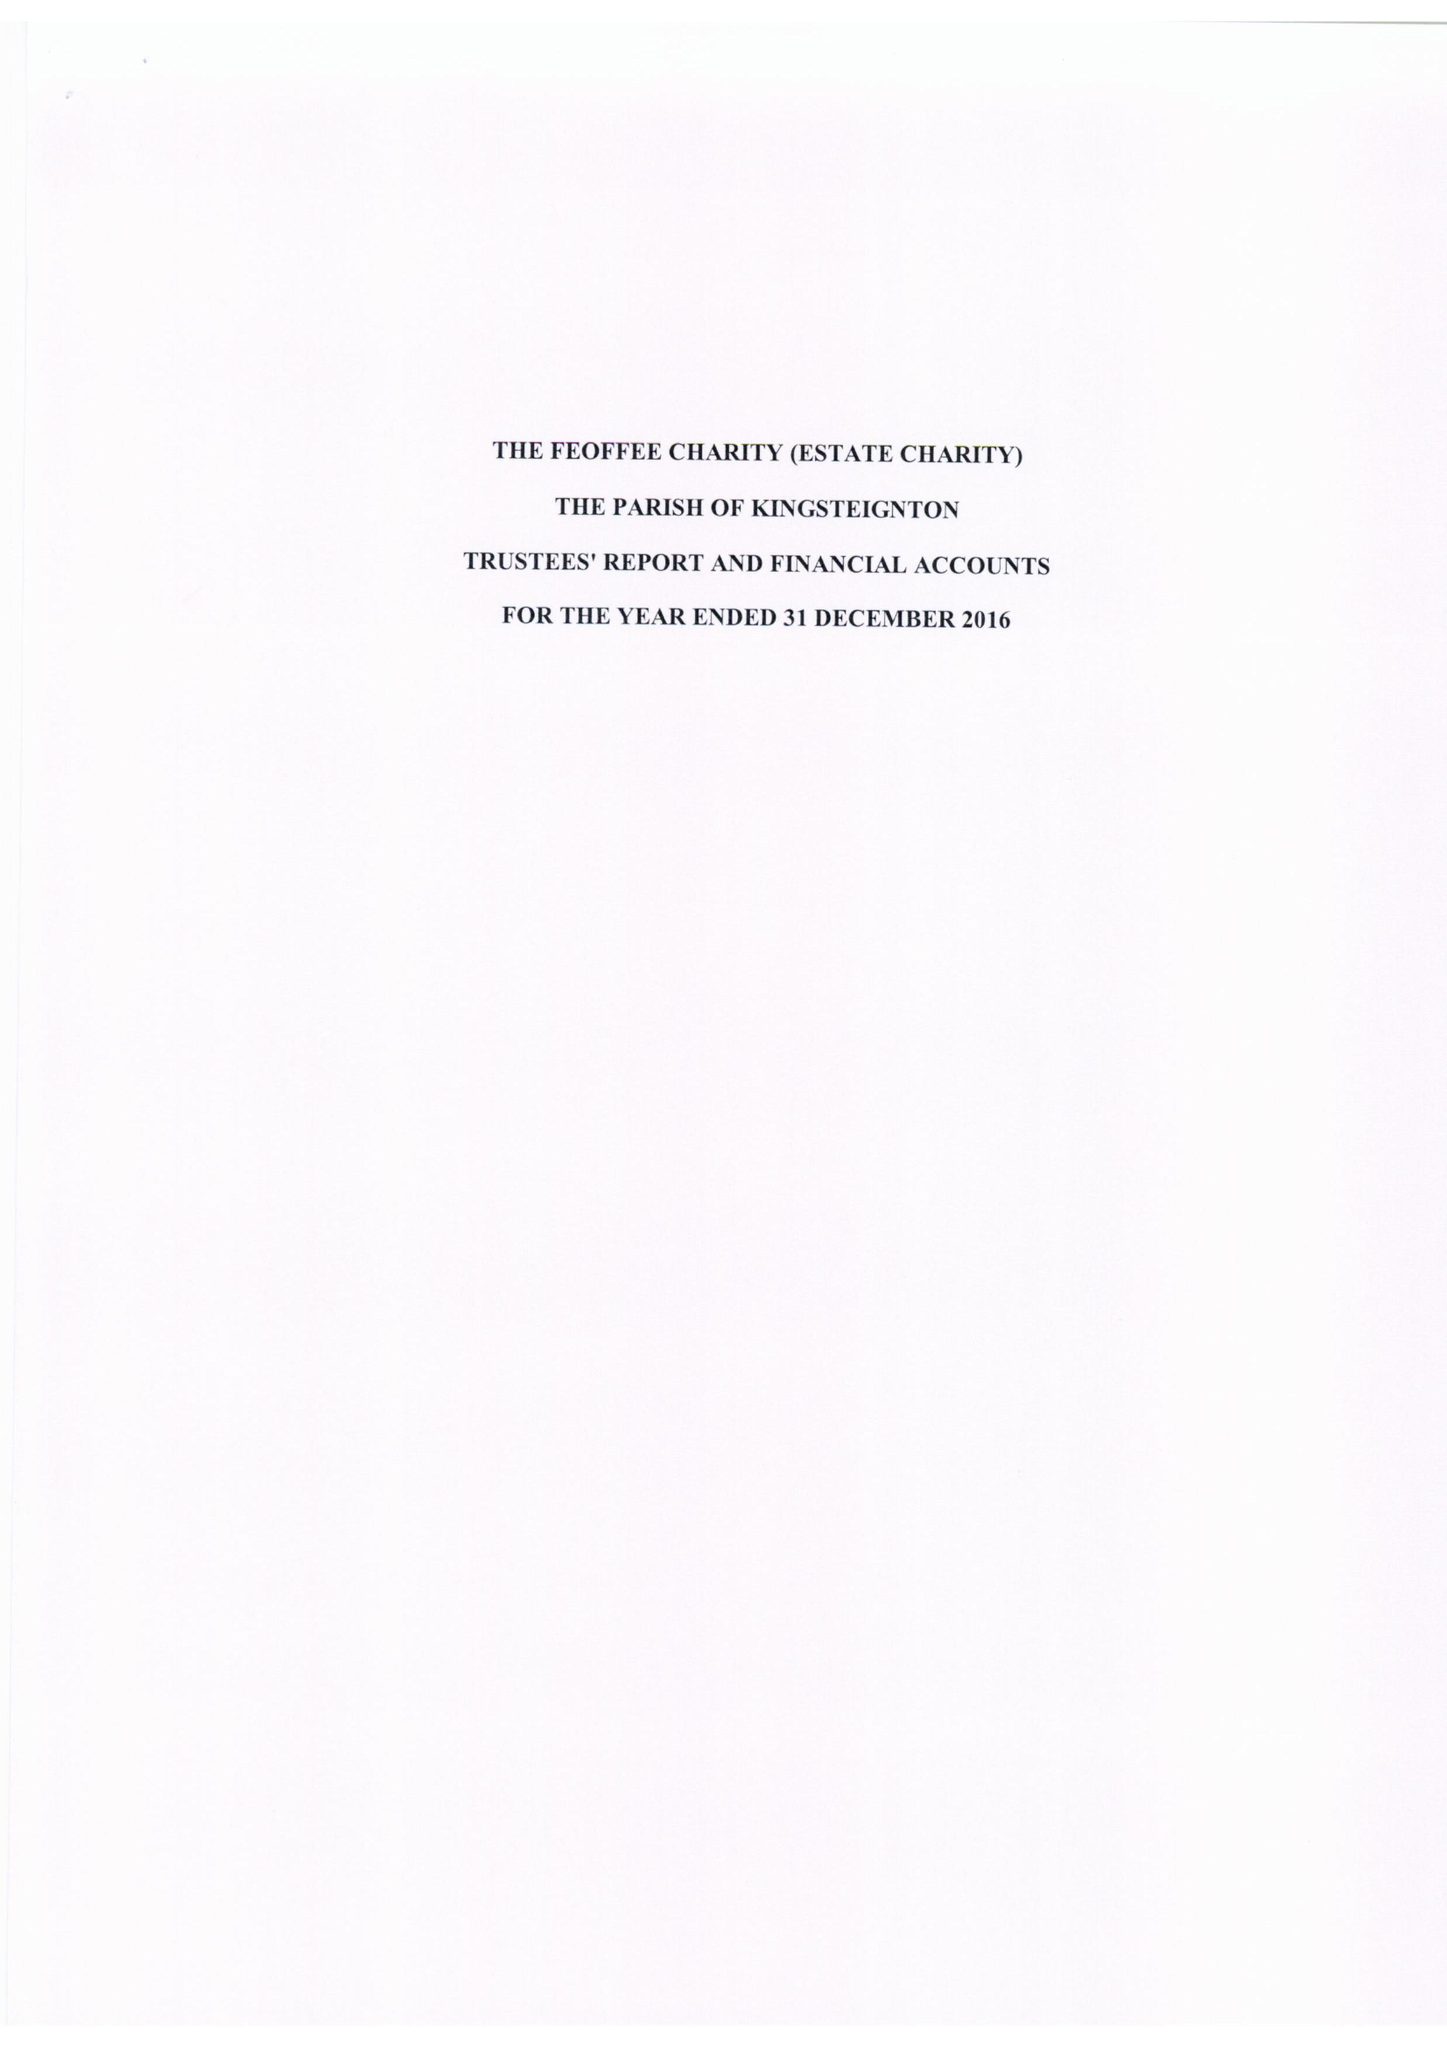What is the value for the address__street_line?
Answer the question using a single word or phrase. None 